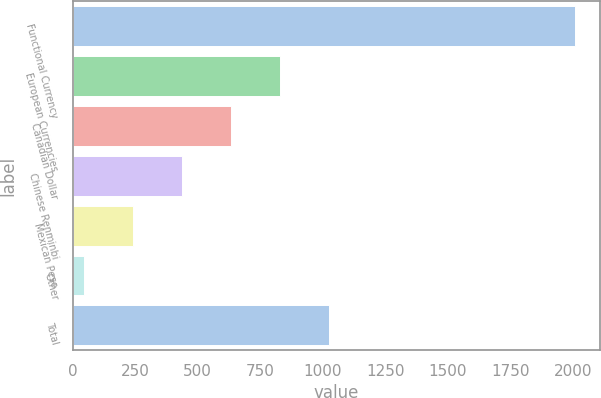Convert chart. <chart><loc_0><loc_0><loc_500><loc_500><bar_chart><fcel>Functional Currency<fcel>European Currencies<fcel>Canadian Dollar<fcel>Chinese Renminbi<fcel>Mexican Peso<fcel>Other<fcel>Total<nl><fcel>2008<fcel>829.9<fcel>633.55<fcel>437.2<fcel>240.85<fcel>44.5<fcel>1026.25<nl></chart> 